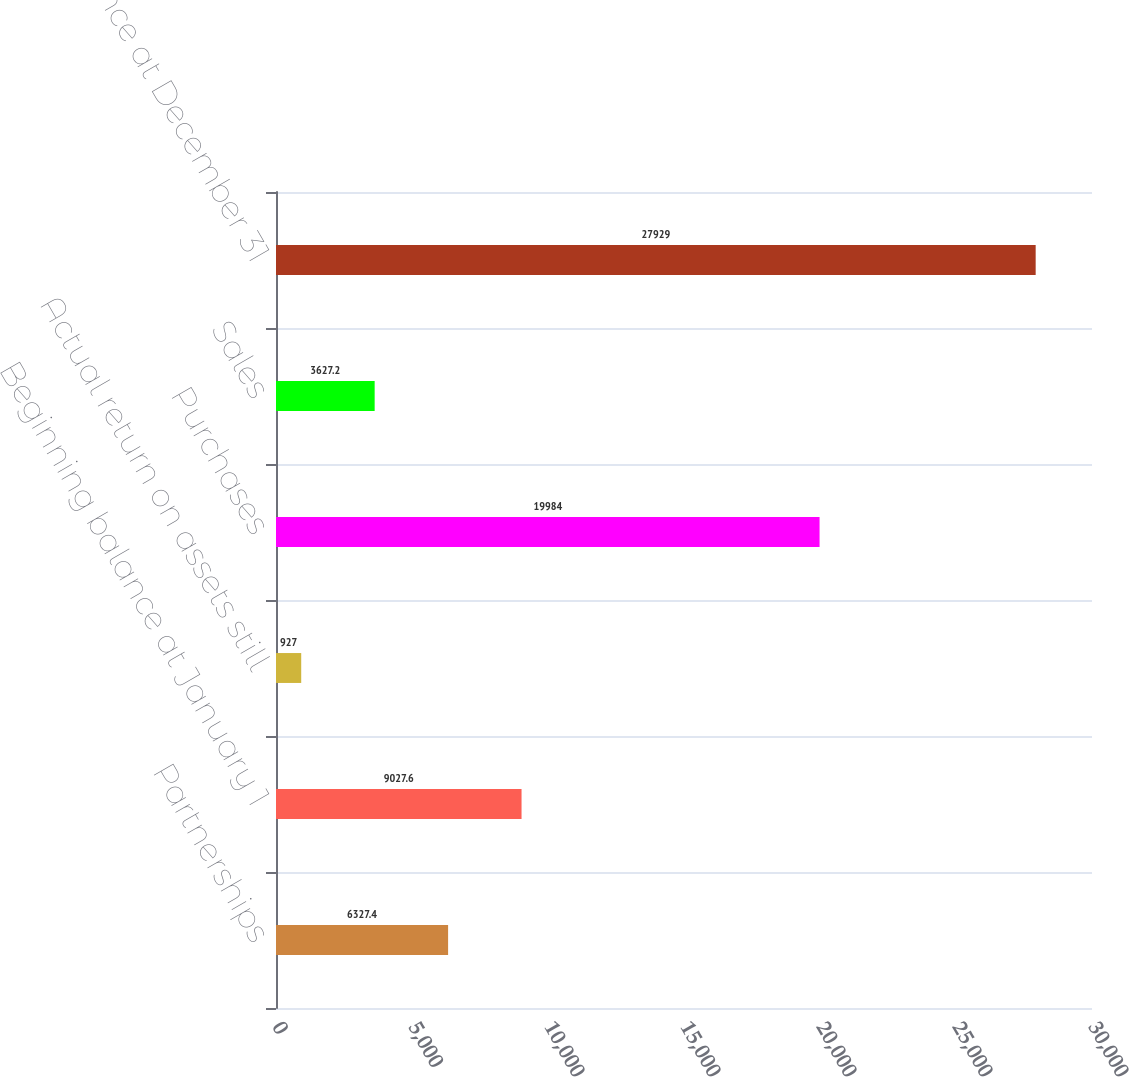Convert chart to OTSL. <chart><loc_0><loc_0><loc_500><loc_500><bar_chart><fcel>Partnerships<fcel>Beginning balance at January 1<fcel>Actual return on assets still<fcel>Purchases<fcel>Sales<fcel>Ending balance at December 31<nl><fcel>6327.4<fcel>9027.6<fcel>927<fcel>19984<fcel>3627.2<fcel>27929<nl></chart> 